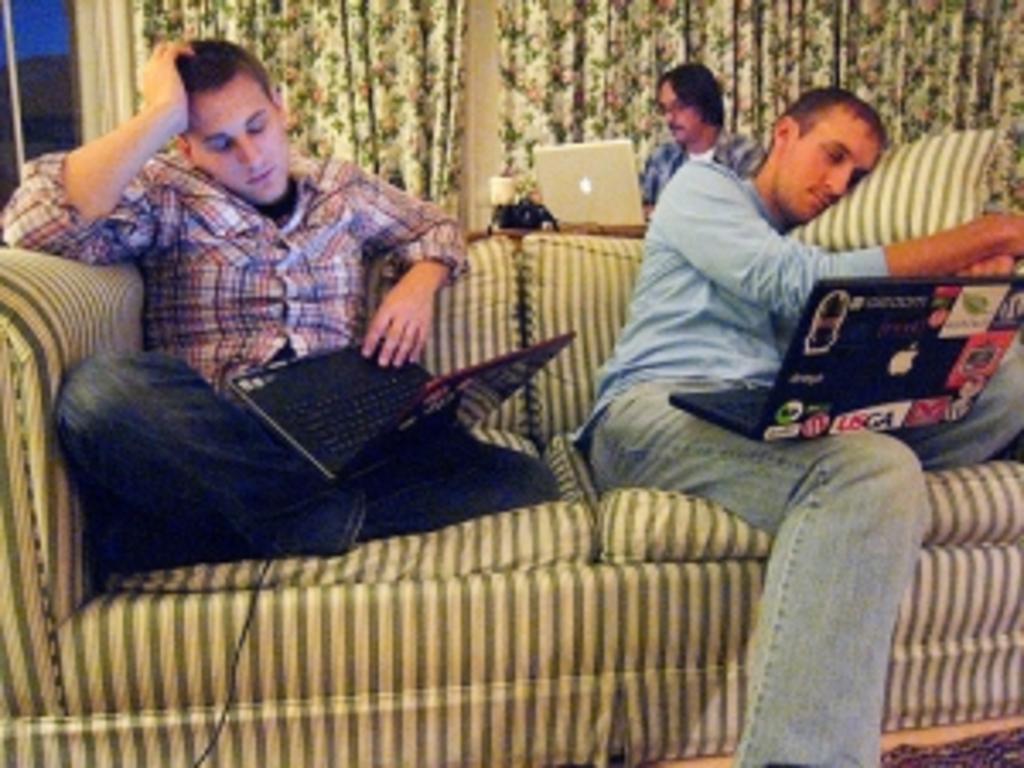Could you give a brief overview of what you see in this image? 2 people are sitting on the sofa holding laptops. behind them another person is sitting operating a laptop. behind them there are curtains. 